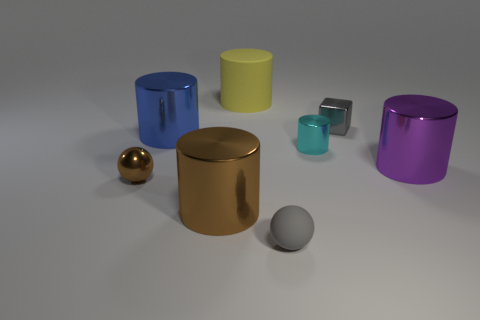Subtract 2 cylinders. How many cylinders are left? 3 Subtract all brown cylinders. How many cylinders are left? 4 Subtract all small metallic cylinders. How many cylinders are left? 4 Subtract all cyan cylinders. Subtract all gray blocks. How many cylinders are left? 4 Add 1 tiny metal objects. How many objects exist? 9 Subtract 0 yellow spheres. How many objects are left? 8 Subtract all blocks. How many objects are left? 7 Subtract all tiny cyan metallic things. Subtract all purple metal things. How many objects are left? 6 Add 6 metallic cubes. How many metallic cubes are left? 7 Add 3 blue shiny cylinders. How many blue shiny cylinders exist? 4 